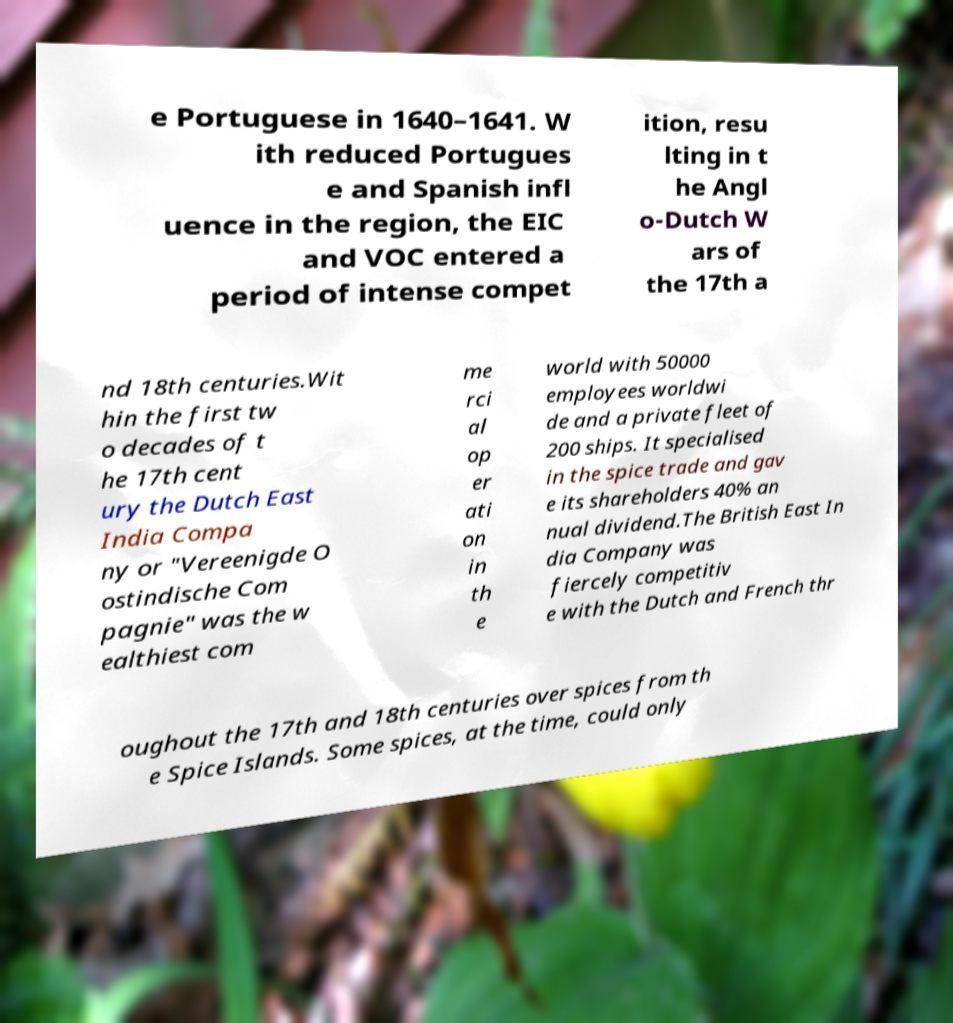What messages or text are displayed in this image? I need them in a readable, typed format. e Portuguese in 1640–1641. W ith reduced Portugues e and Spanish infl uence in the region, the EIC and VOC entered a period of intense compet ition, resu lting in t he Angl o-Dutch W ars of the 17th a nd 18th centuries.Wit hin the first tw o decades of t he 17th cent ury the Dutch East India Compa ny or "Vereenigde O ostindische Com pagnie" was the w ealthiest com me rci al op er ati on in th e world with 50000 employees worldwi de and a private fleet of 200 ships. It specialised in the spice trade and gav e its shareholders 40% an nual dividend.The British East In dia Company was fiercely competitiv e with the Dutch and French thr oughout the 17th and 18th centuries over spices from th e Spice Islands. Some spices, at the time, could only 